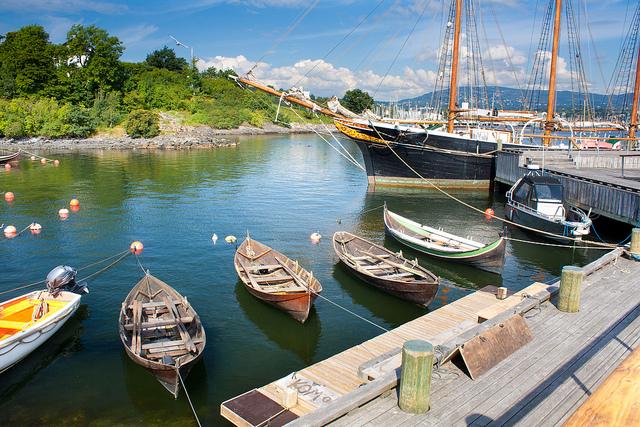What are the boats tied to?
Keep it brief. Dock. How many sailboats are there?
Quick response, please. 1. How many boats are there?
Short answer required. 7. 